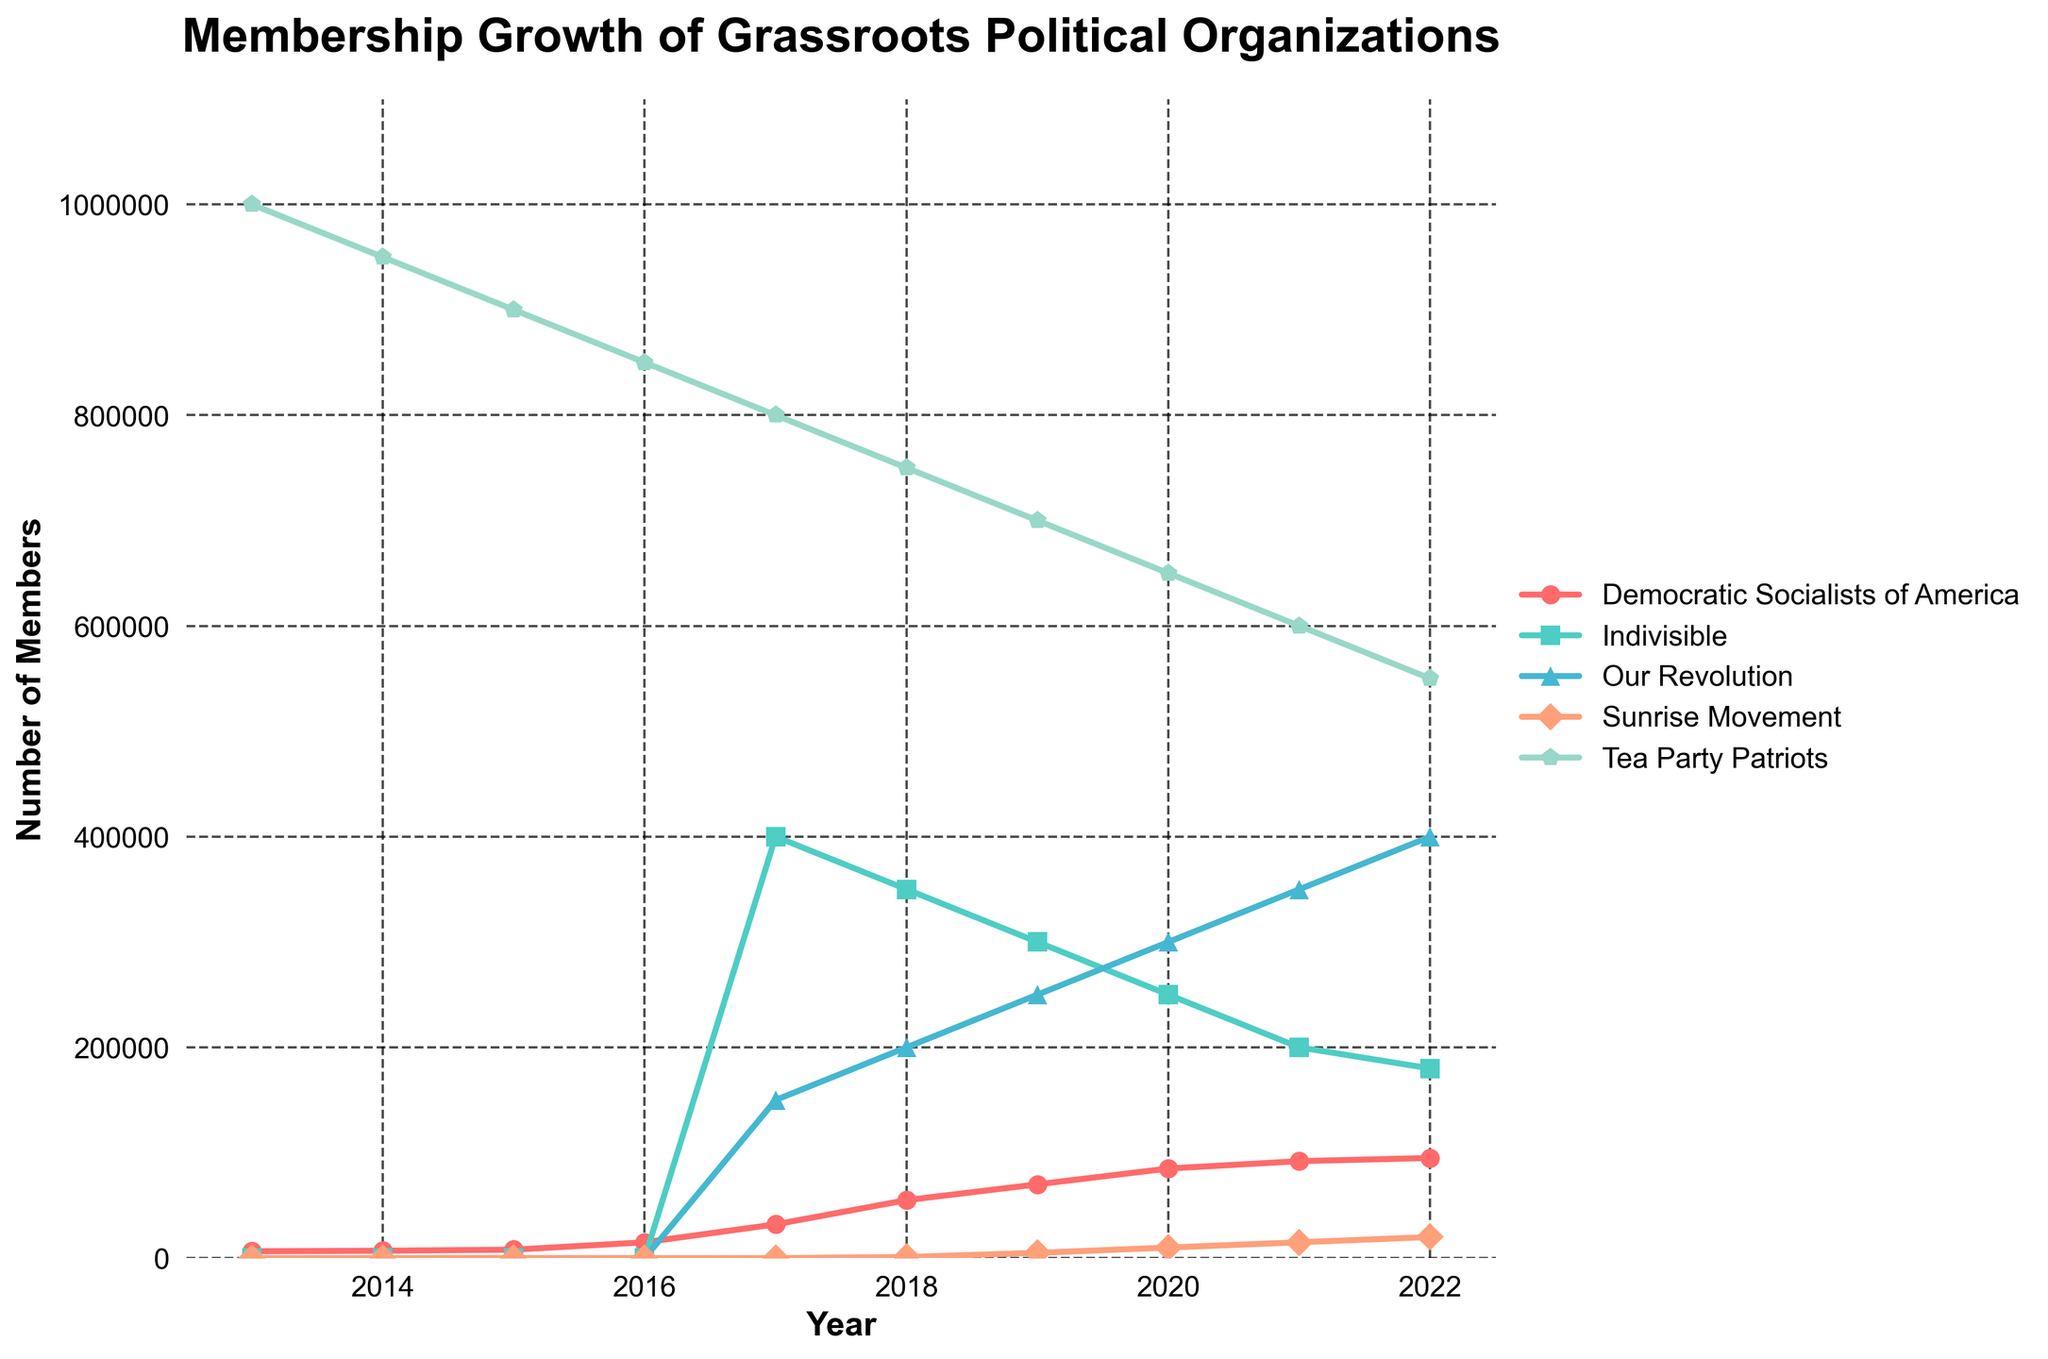Which organization had the highest membership in 2013? Look at the points for each organization in 2013. The Tea Party Patriots had noticeably the highest membership.
Answer: Tea Party Patriots How did the membership of Indivisible change from 2017 to 2022? Check the Indivisible line from 2017 to 2022. It decreased from 400,000 in 2017 to 180,000 in 2022.
Answer: Decreased Which organization showed the most consistent growth over the 10 years? Examine the trend for each organization over the decade. The Democratic Socialists of America showed a steady increase without drops.
Answer: Democratic Socialists of America What is the combined membership of Our Revolution and Sunrise Movement in 2020? Add the membership numbers for both in 2020: 300,000 (Our Revolution) + 10,000 (Sunrise Movement).
Answer: 310,000 Which year did the Sunrise Movement first appear in the data? Identify when the Sunrise Movement line first starts. It starts in 2018.
Answer: 2018 What was the rate of membership decline for the Tea Party Patriots between 2013 and 2017? Calculate the difference between the membership in 2013 and 2017, then divide by the number of years: (1,000,000 - 800,000) / 4.
Answer: 50,000 per year Which organization had the smallest membership in 2022? Look at the membership values for each organization in 2022. The Sunrise Movement had the smallest membership.
Answer: Sunrise Movement In which year did the Democratic Socialists of America see the largest increase in membership from the previous year? Find the year-to-year differences for the Democratic Socialists of America and identify the largest jump. It occurred between 2015 and 2016, increasing from 8,000 to 15,000.
Answer: 2016 By how much did the membership of Our Revolution increase from 2017 to 2022? Subtract the membership of 2017 from that of 2022 for Our Revolution: 400,000 - 150,000.
Answer: 250,000 